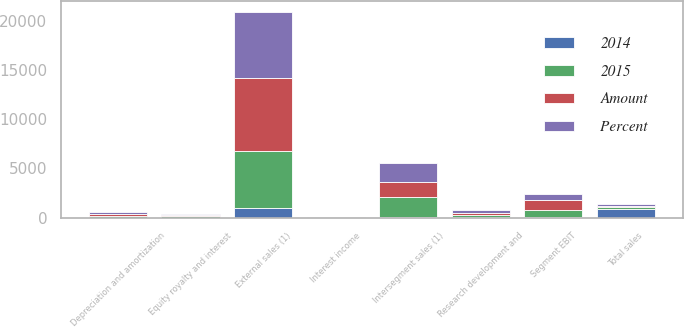<chart> <loc_0><loc_0><loc_500><loc_500><stacked_bar_chart><ecel><fcel>External sales (1)<fcel>Intersegment sales (1)<fcel>Total sales<fcel>Depreciation and amortization<fcel>Research development and<fcel>Equity royalty and interest<fcel>Interest income<fcel>Segment EBIT<nl><fcel>2015<fcel>5774<fcel>2030<fcel>187<fcel>163<fcel>226<fcel>148<fcel>10<fcel>686<nl><fcel>Percent<fcel>6733<fcel>1937<fcel>187<fcel>187<fcel>263<fcel>146<fcel>11<fcel>636<nl><fcel>Amount<fcel>7462<fcel>1505<fcel>187<fcel>163<fcel>265<fcel>118<fcel>9<fcel>1031<nl><fcel>2014<fcel>959<fcel>93<fcel>866<fcel>24<fcel>37<fcel>2<fcel>1<fcel>50<nl></chart> 